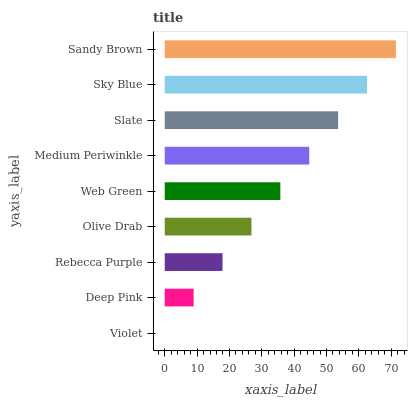Is Violet the minimum?
Answer yes or no. Yes. Is Sandy Brown the maximum?
Answer yes or no. Yes. Is Deep Pink the minimum?
Answer yes or no. No. Is Deep Pink the maximum?
Answer yes or no. No. Is Deep Pink greater than Violet?
Answer yes or no. Yes. Is Violet less than Deep Pink?
Answer yes or no. Yes. Is Violet greater than Deep Pink?
Answer yes or no. No. Is Deep Pink less than Violet?
Answer yes or no. No. Is Web Green the high median?
Answer yes or no. Yes. Is Web Green the low median?
Answer yes or no. Yes. Is Medium Periwinkle the high median?
Answer yes or no. No. Is Violet the low median?
Answer yes or no. No. 